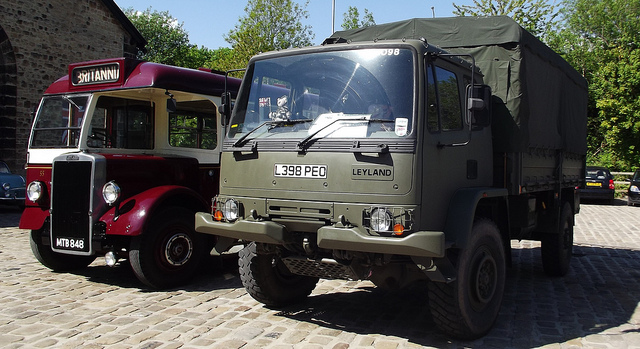Read and extract the text from this image. BRITANNI NTB 8848 LEYLANF L398 PEO 098 